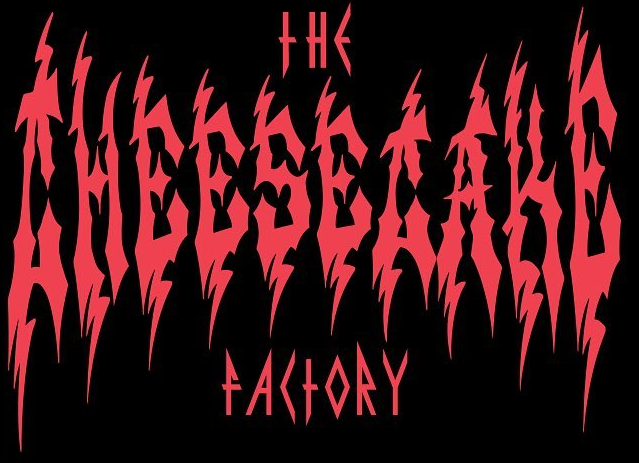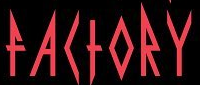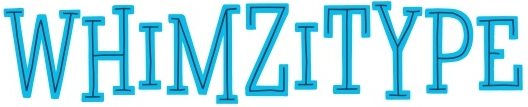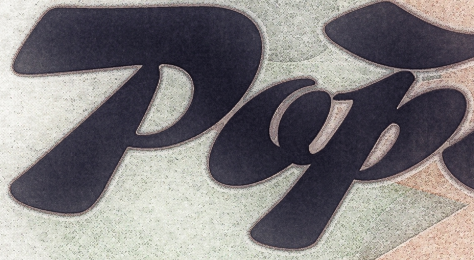Read the text from these images in sequence, separated by a semicolon. CHEESECAKE; FACTORY; WHIMZITYPE; Pop 